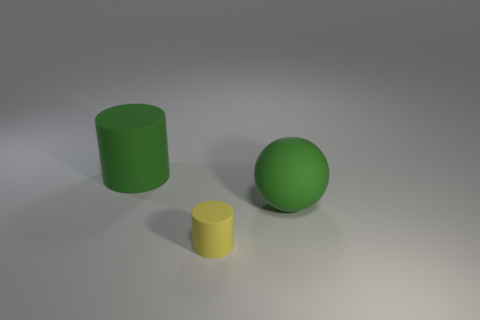Add 3 large green rubber spheres. How many objects exist? 6 Subtract all spheres. How many objects are left? 2 Add 1 large spheres. How many large spheres are left? 2 Add 3 tiny red metallic balls. How many tiny red metallic balls exist? 3 Subtract 0 blue cubes. How many objects are left? 3 Subtract all green rubber blocks. Subtract all yellow matte things. How many objects are left? 2 